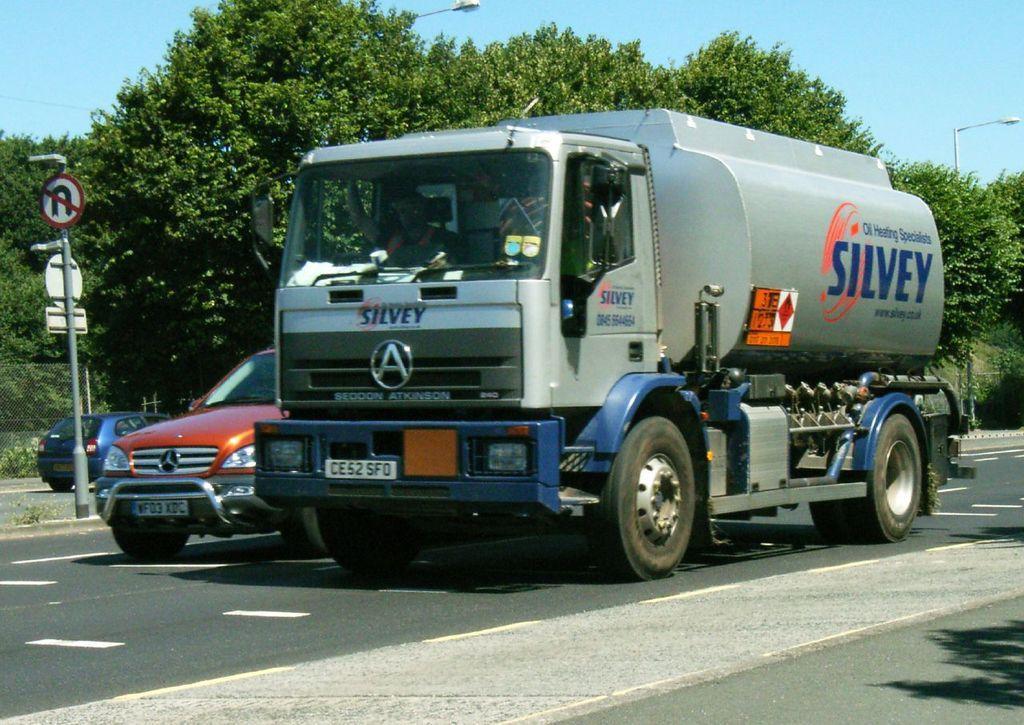Please provide a concise description of this image. In this picture there is a lorry. Beside the lorry there is a car on the road. In the middle of the road there is a pole. In the background there are trees and a sky here. 